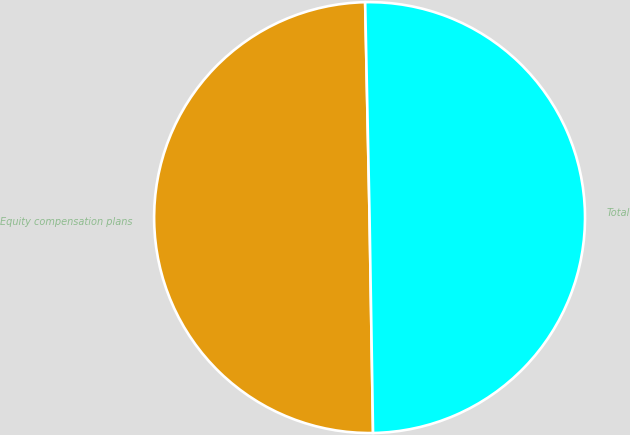Convert chart. <chart><loc_0><loc_0><loc_500><loc_500><pie_chart><fcel>Equity compensation plans<fcel>Total<nl><fcel>49.93%<fcel>50.07%<nl></chart> 